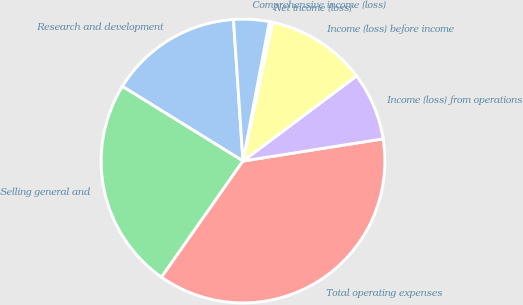Convert chart to OTSL. <chart><loc_0><loc_0><loc_500><loc_500><pie_chart><fcel>Research and development<fcel>Selling general and<fcel>Total operating expenses<fcel>Income (loss) from operations<fcel>Income (loss) before income<fcel>Net income (loss)<fcel>Comprehensive income (loss)<nl><fcel>15.11%<fcel>24.08%<fcel>37.24%<fcel>7.74%<fcel>11.42%<fcel>0.36%<fcel>4.05%<nl></chart> 